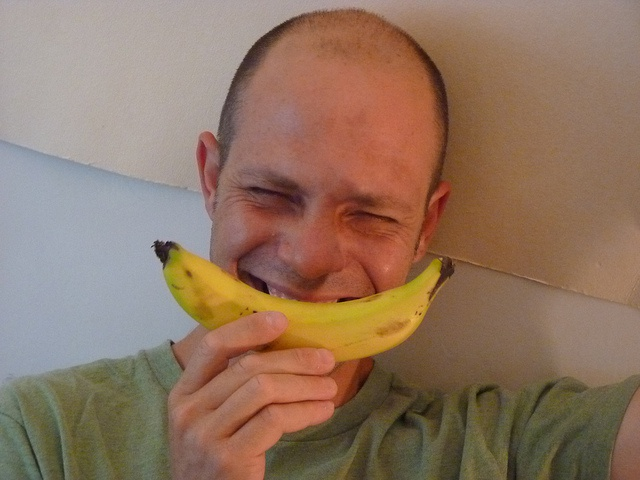Describe the objects in this image and their specific colors. I can see people in darkgray, brown, darkgreen, and gray tones and banana in darkgray, orange, and olive tones in this image. 